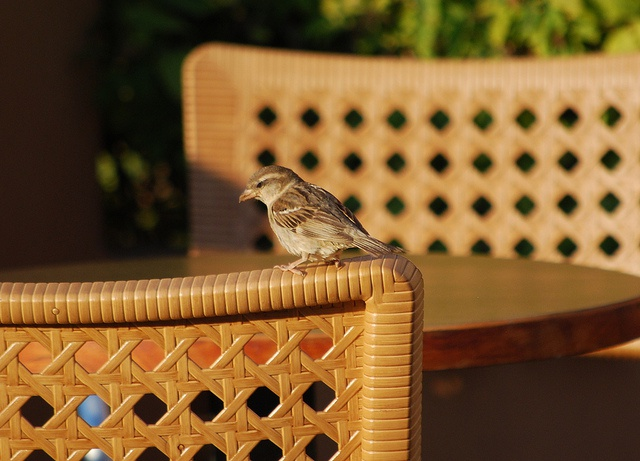Describe the objects in this image and their specific colors. I can see chair in black, tan, and olive tones, chair in black, red, and orange tones, dining table in black, olive, and maroon tones, chair in black, tan, red, and orange tones, and bird in black, tan, brown, maroon, and gray tones in this image. 